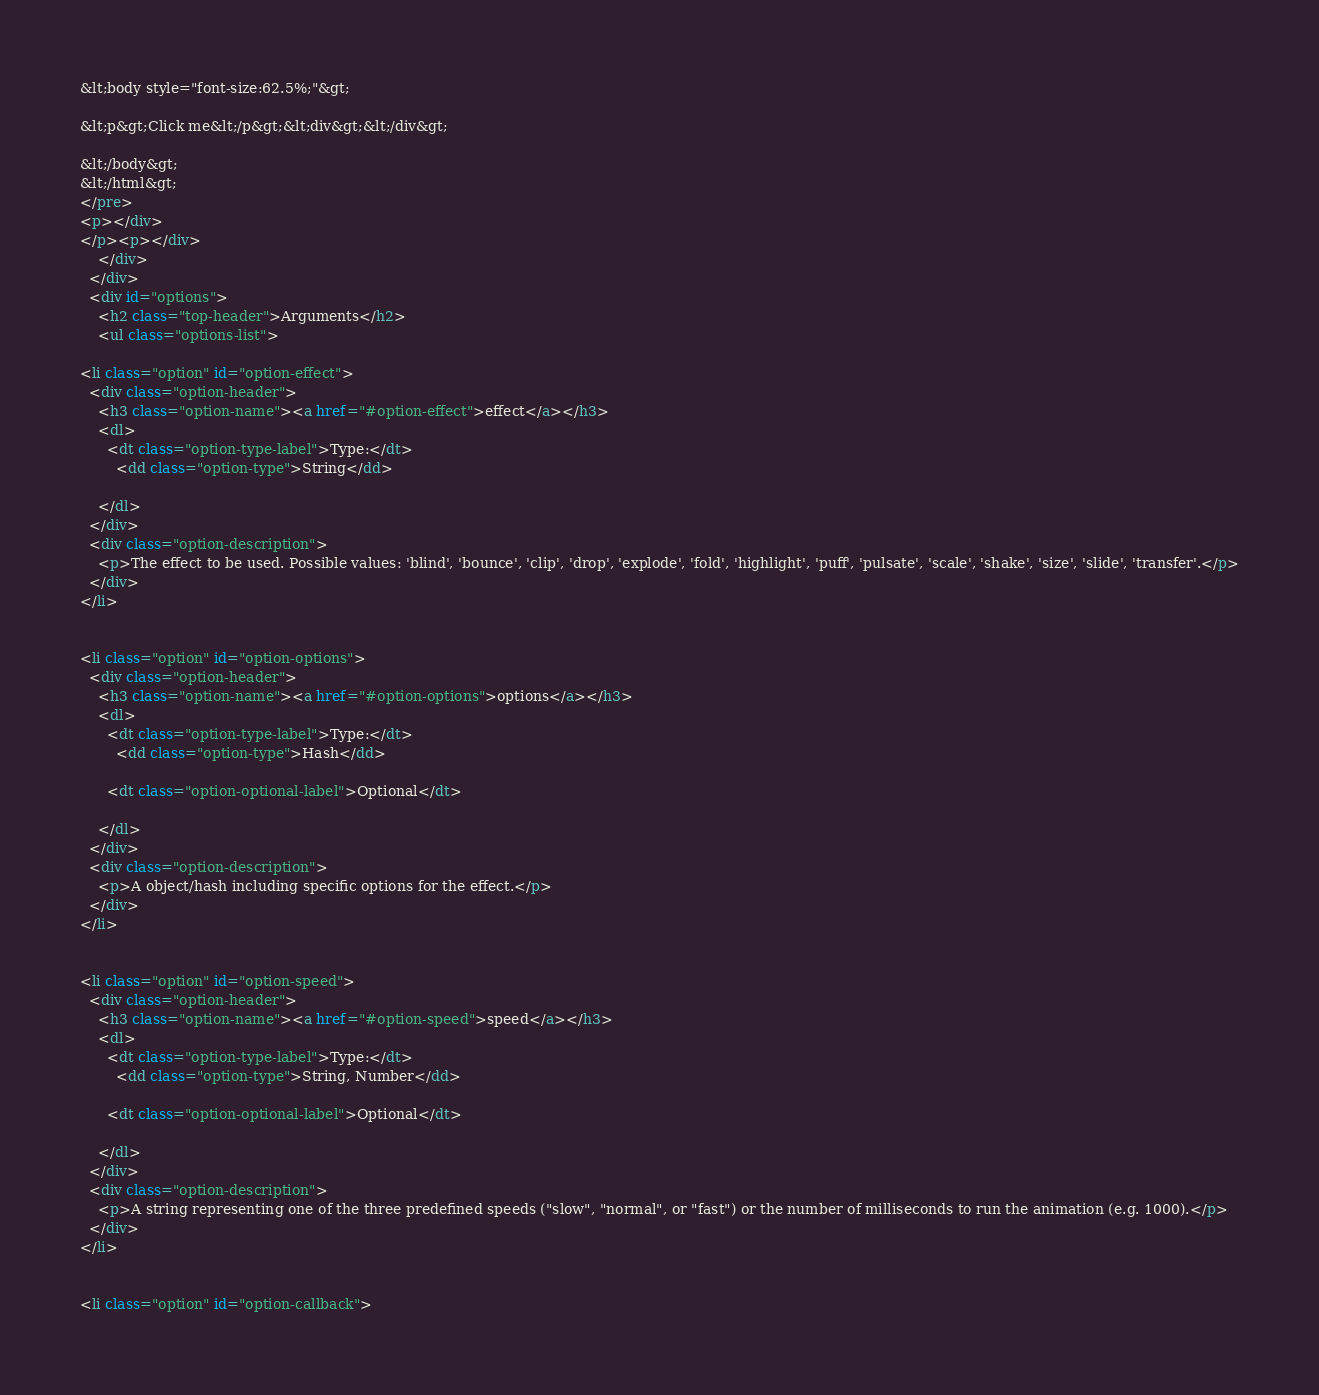<code> <loc_0><loc_0><loc_500><loc_500><_HTML_>&lt;body style="font-size:62.5%;"&gt;
  
&lt;p&gt;Click me&lt;/p&gt;&lt;div&gt;&lt;/div&gt;

&lt;/body&gt;
&lt;/html&gt;
</pre>
<p></div>
</p><p></div>
    </div>
  </div>
  <div id="options">
    <h2 class="top-header">Arguments</h2>
    <ul class="options-list">
      
<li class="option" id="option-effect">
  <div class="option-header">
    <h3 class="option-name"><a href="#option-effect">effect</a></h3>
    <dl>
      <dt class="option-type-label">Type:</dt>
        <dd class="option-type">String</dd>
      
    </dl>
  </div>
  <div class="option-description">
    <p>The effect to be used. Possible values: 'blind', 'bounce', 'clip', 'drop', 'explode', 'fold', 'highlight', 'puff', 'pulsate', 'scale', 'shake', 'size', 'slide', 'transfer'.</p>
  </div>
</li>


<li class="option" id="option-options">
  <div class="option-header">
    <h3 class="option-name"><a href="#option-options">options</a></h3>
    <dl>
      <dt class="option-type-label">Type:</dt>
        <dd class="option-type">Hash</dd>
      
      <dt class="option-optional-label">Optional</dt>
      
    </dl>
  </div>
  <div class="option-description">
    <p>A object/hash including specific options for the effect.</p>
  </div>
</li>


<li class="option" id="option-speed">
  <div class="option-header">
    <h3 class="option-name"><a href="#option-speed">speed</a></h3>
    <dl>
      <dt class="option-type-label">Type:</dt>
        <dd class="option-type">String, Number</dd>
      
      <dt class="option-optional-label">Optional</dt>
      
    </dl>
  </div>
  <div class="option-description">
    <p>A string representing one of the three predefined speeds ("slow", "normal", or "fast") or the number of milliseconds to run the animation (e.g. 1000).</p>
  </div>
</li>


<li class="option" id="option-callback"></code> 